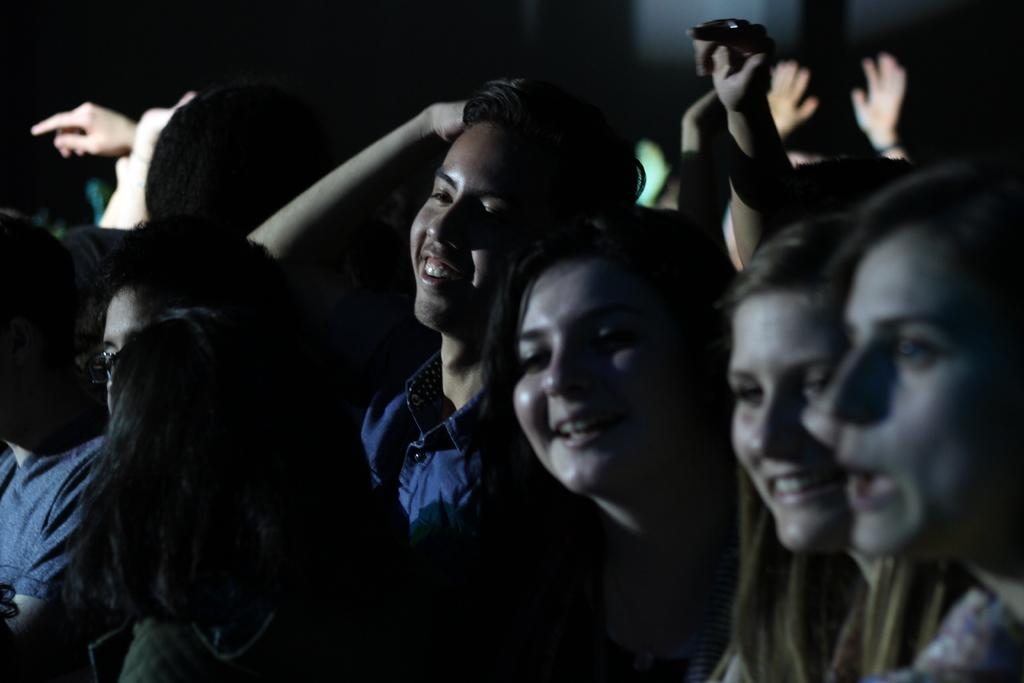What are the people in the image doing? The people in the image are standing and smiling. Can you describe the person at the center of the image? The person at the center of the image is wearing a blue shirt. What is the overall mood of the people in the image? The people in the image are smiling, which suggests a positive or happy mood. What degree does the person at the center of the image have? There is no information about the person's degree in the image. How many children were born during the event depicted in the image? There is no event or mention of births in the image. 